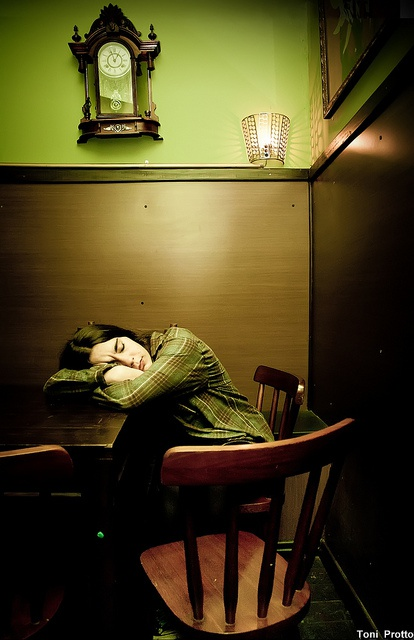Describe the objects in this image and their specific colors. I can see chair in black, maroon, and brown tones, people in black, olive, and khaki tones, chair in black, olive, tan, and maroon tones, dining table in black, maroon, and olive tones, and chair in black, maroon, olive, and brown tones in this image. 